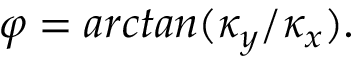Convert formula to latex. <formula><loc_0><loc_0><loc_500><loc_500>\varphi = a r c t a n ( \kappa _ { y } / \kappa _ { x } ) .</formula> 